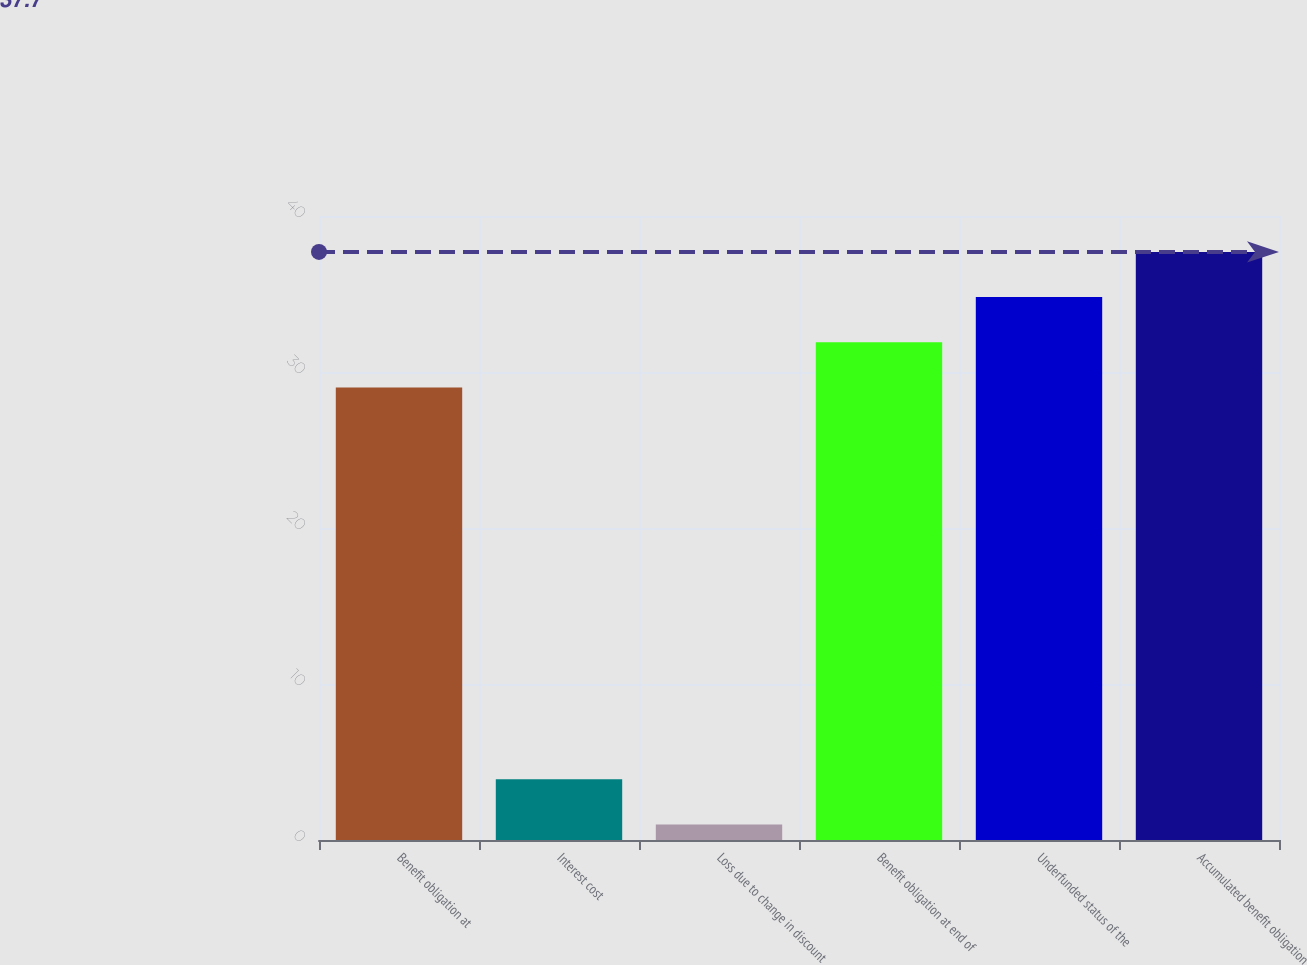Convert chart to OTSL. <chart><loc_0><loc_0><loc_500><loc_500><bar_chart><fcel>Benefit obligation at<fcel>Interest cost<fcel>Loss due to change in discount<fcel>Benefit obligation at end of<fcel>Underfunded status of the<fcel>Accumulated benefit obligation<nl><fcel>29<fcel>3.9<fcel>1<fcel>31.9<fcel>34.8<fcel>37.7<nl></chart> 